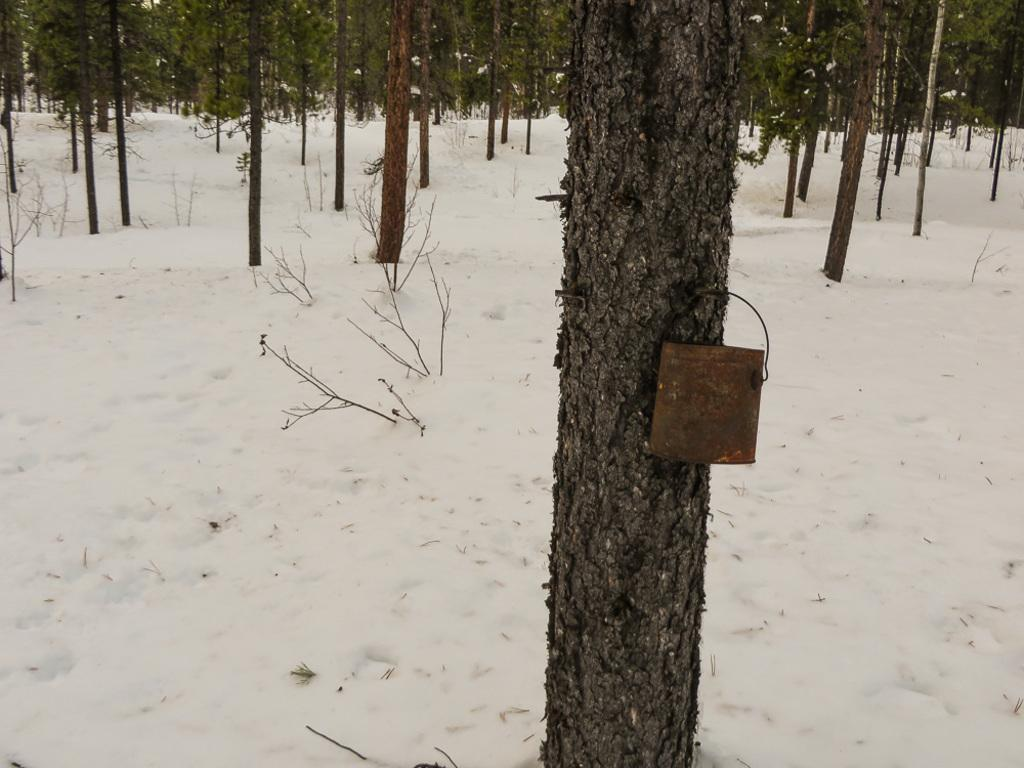What type of vegetation is present in the image? There are trees with branches and leaves in the image. What is the weather like in the image? There is snow in the image, indicating a cold or wintery environment. What object with rust can be seen in the image? There is a small iron bucket with rust in the image. Where is the iron bucket located in the image? The iron bucket is hanging on a tree trunk. What type of window can be seen in the image? There is no window present in the image. What show is being performed by the trees in the image? There is no show being performed by the trees in the image; they are simply trees with branches and leaves. 